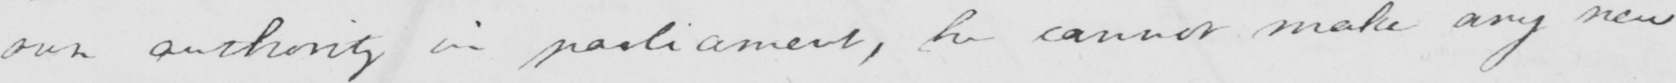Transcribe the text shown in this historical manuscript line. own authority in parliament , he cannot make any new 